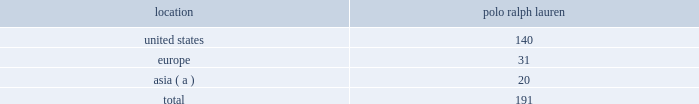Table of contents 2022 rugby is a vertical retail format featuring an aspirational lifestyle collection of apparel and accessories for men and women .
The brand is characterized by a youthful , preppy attitude which resonates throughout the line and the store experience .
In addition to generating sales of our products , our worldwide full-price stores set , reinforce and capitalize on the image of our brands .
Our stores range in size from approximately 800 to over 38000 square feet .
These full-price stores are situated in major upscale street locations and upscale regional malls , generally in large urban markets .
We generally lease our stores for initial periods ranging from 5 to 10 years with renewal options .
Factory retail stores we extend our reach to additional consumer groups through our 191 polo ralph lauren factory stores worldwide .
Our factory stores are generally located in outlet centers .
We generally lease our stores for initial periods ranging from 5 to 10 years with renewal options .
During fiscal 2011 , we added 19 new polo ralph lauren factory stores , net , and assumed 2 factory stores in connection with the south korea licensed operations acquisition ( see 201crecent developments 201d for further discussion ) .
We operated the following factory retail stores as of april 2 , 2011 : location ralph lauren .
( a ) includes japan , south korea , china , hong kong , indonesia , malaysia , the philippines , singapore , taiwan and thailand .
2022 polo ralph lauren domestic factory stores offer selections of our menswear , womenswear , children 2019s apparel , accessories , home furnishings and fragrances .
Ranging in size from approximately 2500 to 20000 square feet , with an average of approximately 9500 square feet , these stores are principally located in major outlet centers in 37 states and puerto rico .
2022 europe factory stores offer selections of our menswear , womenswear , children 2019s apparel , accessories , home furnishings and fragrances .
Ranging in size from approximately 2300 to 10500 square feet , with an average of approximately 6000 square feet , these stores are located in 11 countries , principally in major outlet centers .
2022 asia factory stores offer selections of our menswear , womenswear , children 2019s apparel , accessories and fragrances .
Ranging in size from approximately 1000 to 12000 square feet , with an average of approximately 5000 square feet , these stores are primarily located throughout japan and in or near other major cities within the asia-pacific region , principally in major outlet centers .
Factory stores obtain products from our suppliers , our product licensing partners and our retail and e-commerce stores .
Concessions-based shop-within-shops in asia , the terms of trade for shop-within-shops are largely conducted on a concessions basis , whereby inventory continues to be owned by us ( not the department store ) until ultimate sale to the end consumer and the salespeople involved in the sales transaction are generally our employees .
As of april 2 , 2011 , we had 510 concessions-based shop-within-shops at approximately 236 retail locations dedicated to our ralph lauren-branded products , primarily in asia , including 178 concessions-based shop-in-shops related to the south korea licensed operations acquisition .
The size of our concessions-based shop-within-shops typically ranges from approximately 180 to 3600 square feet .
We share in the cost of these shop-within-shops with our department store partners. .
What percentage of factory retail stores as of april 2 , 2011 is asia? 
Computations: (20 / 191)
Answer: 0.10471. 